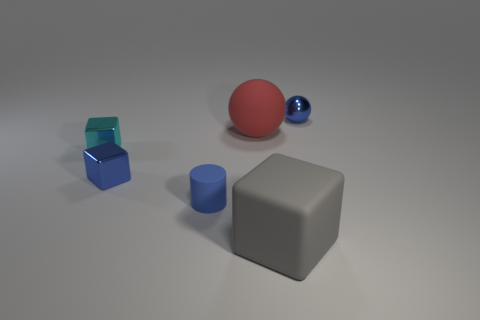Add 2 big purple shiny cubes. How many objects exist? 8 Subtract all cylinders. How many objects are left? 5 Add 6 big yellow objects. How many big yellow objects exist? 6 Subtract 0 red cylinders. How many objects are left? 6 Subtract all blue matte cubes. Subtract all tiny blue balls. How many objects are left? 5 Add 1 small cubes. How many small cubes are left? 3 